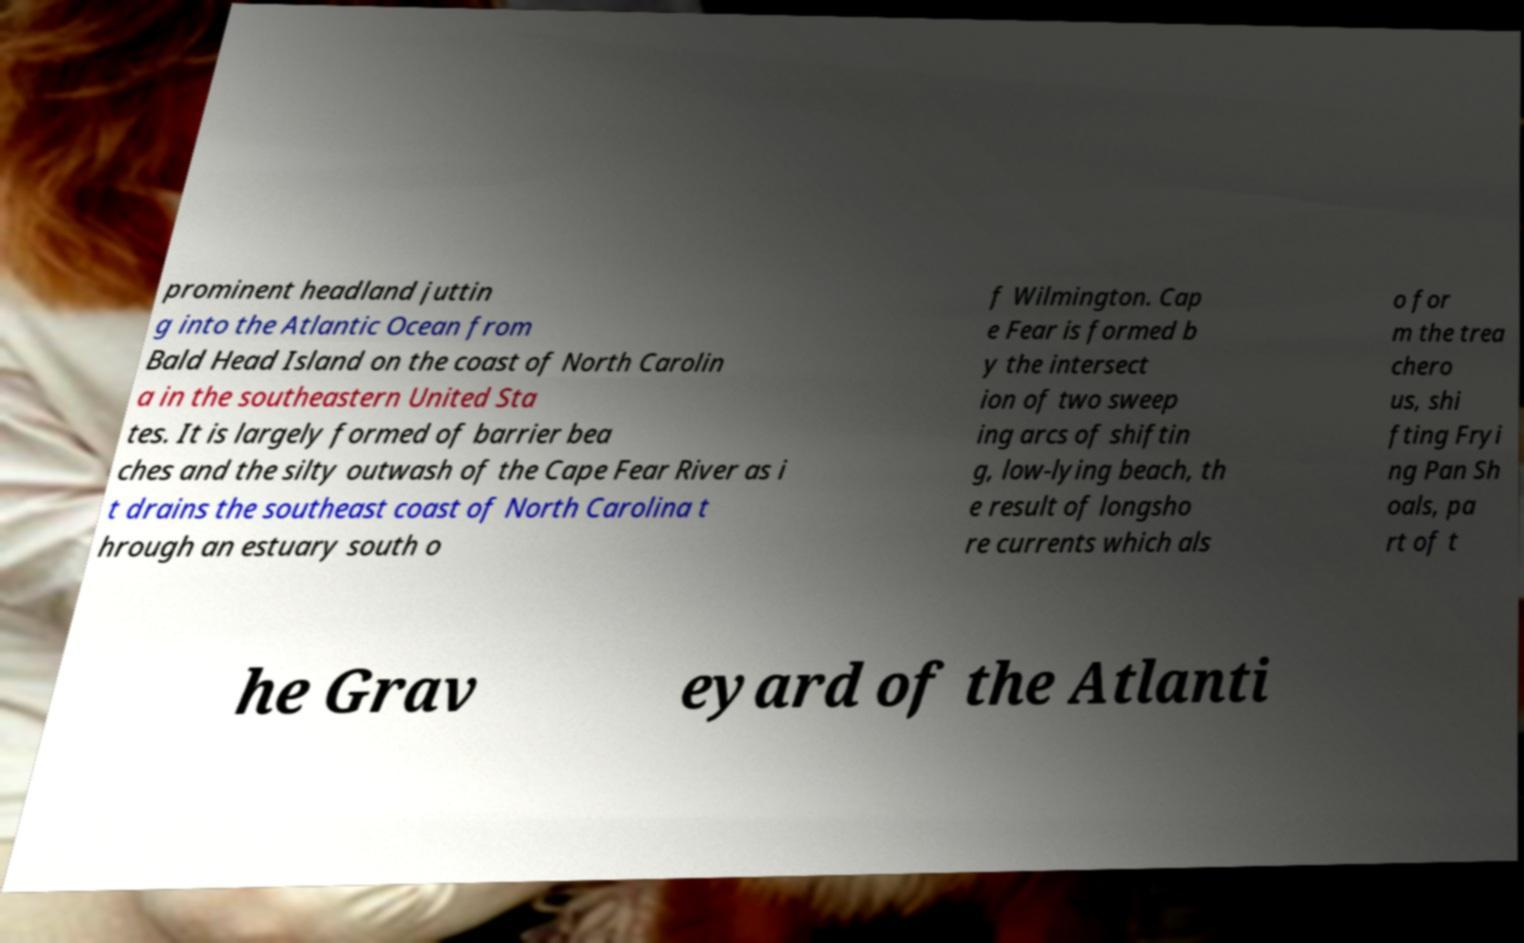What messages or text are displayed in this image? I need them in a readable, typed format. prominent headland juttin g into the Atlantic Ocean from Bald Head Island on the coast of North Carolin a in the southeastern United Sta tes. It is largely formed of barrier bea ches and the silty outwash of the Cape Fear River as i t drains the southeast coast of North Carolina t hrough an estuary south o f Wilmington. Cap e Fear is formed b y the intersect ion of two sweep ing arcs of shiftin g, low-lying beach, th e result of longsho re currents which als o for m the trea chero us, shi fting Fryi ng Pan Sh oals, pa rt of t he Grav eyard of the Atlanti 